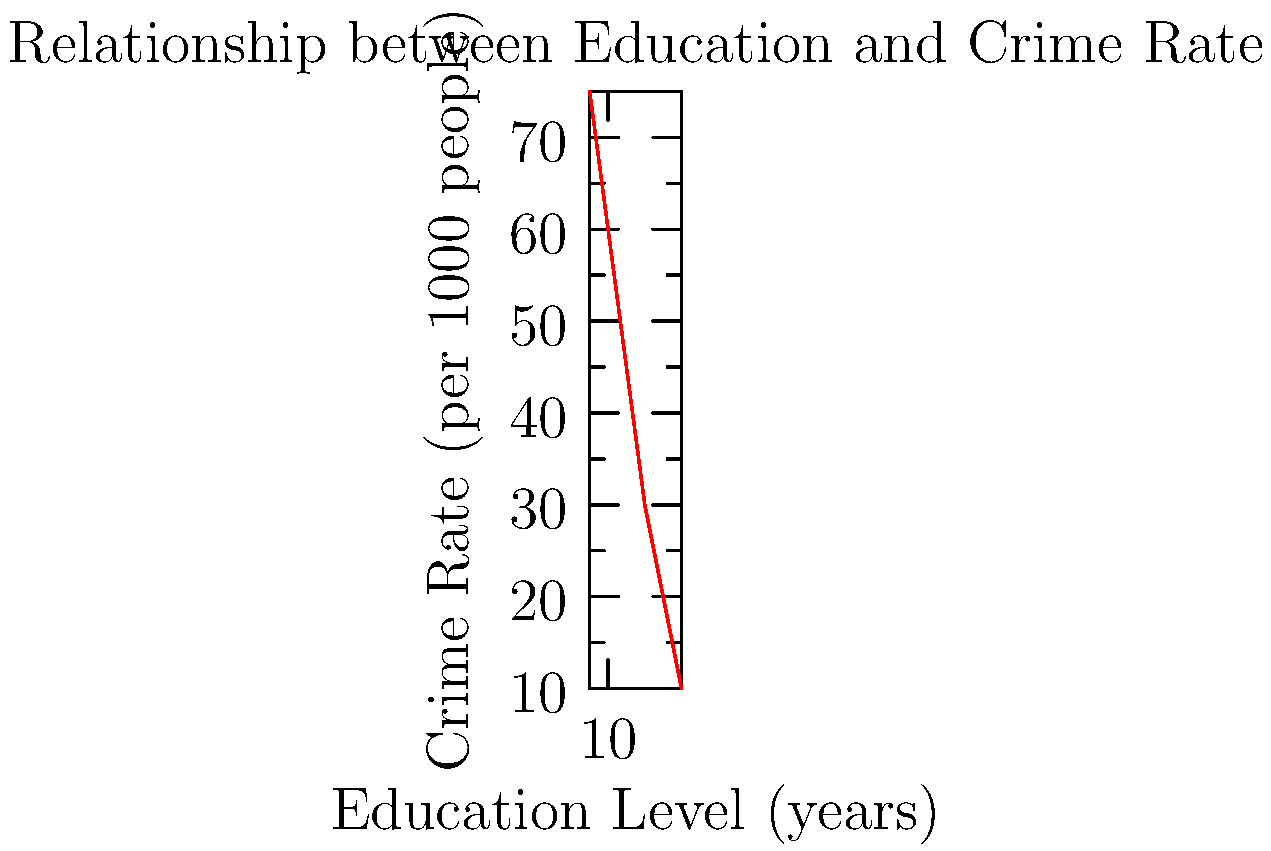Based on the scatter plot showing the relationship between education level and crime rate, what trend can be observed? How might this information be useful in developing criminal justice policies? 1. Observe the scatter plot: The x-axis represents education level in years, while the y-axis shows the crime rate per 1000 people.

2. Identify the trend: As education level increases, the crime rate decreases. This is evident from the downward slope of the plot from left to right.

3. Quantify the relationship: The plot shows an inverse relationship between education and crime rate. For example, at 8 years of education, the crime rate is about 75 per 1000 people, while at 18 years of education, it drops to about 10 per 1000 people.

4. Consider policy implications: This data suggests that investing in education could potentially reduce crime rates. Policymakers might consider:
   a) Increasing funding for education programs
   b) Implementing educational initiatives in high-crime areas
   c) Offering educational opportunities as part of rehabilitation programs for offenders

5. Limitations: While the trend is clear, it's important to note that correlation does not imply causation. Other factors may influence both education levels and crime rates.

6. Further analysis: Policymakers might want to investigate:
   a) The specific types of education that have the most impact on reducing crime
   b) The cost-effectiveness of education programs versus traditional crime prevention methods
   c) The long-term effects of increased education on recidivism rates
Answer: Inverse relationship between education and crime rate; suggests potential for education-focused crime reduction policies. 